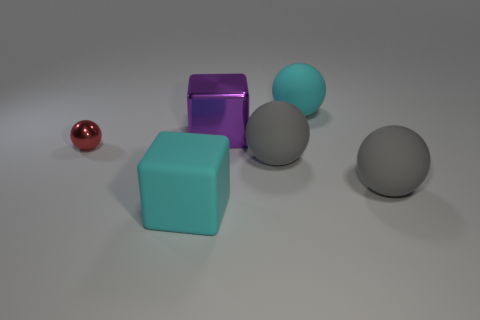Subtract all large rubber spheres. How many spheres are left? 1 Add 1 small metal balls. How many objects exist? 7 Subtract all purple blocks. How many blocks are left? 1 Subtract 3 balls. How many balls are left? 1 Subtract all blue balls. Subtract all green cubes. How many balls are left? 4 Subtract all green balls. How many purple blocks are left? 1 Subtract all yellow rubber spheres. Subtract all large purple things. How many objects are left? 5 Add 6 matte cubes. How many matte cubes are left? 7 Add 1 red metallic objects. How many red metallic objects exist? 2 Subtract 0 purple balls. How many objects are left? 6 